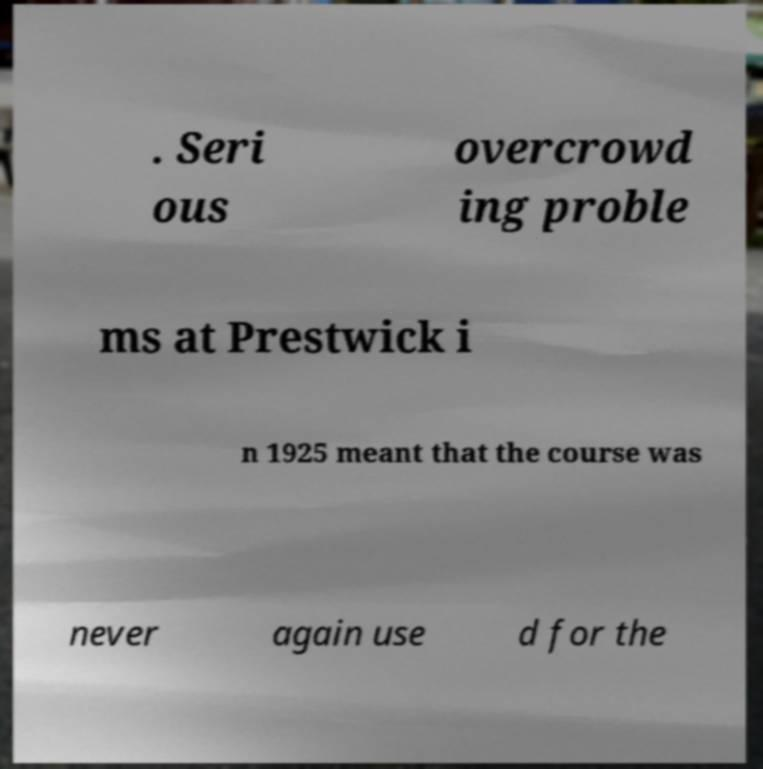For documentation purposes, I need the text within this image transcribed. Could you provide that? . Seri ous overcrowd ing proble ms at Prestwick i n 1925 meant that the course was never again use d for the 